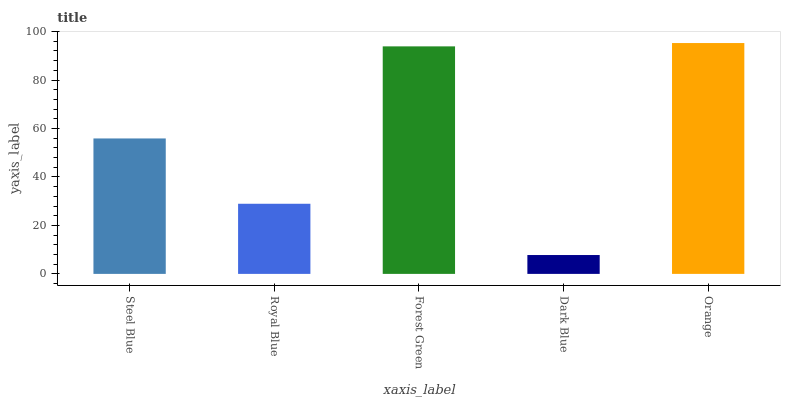Is Dark Blue the minimum?
Answer yes or no. Yes. Is Orange the maximum?
Answer yes or no. Yes. Is Royal Blue the minimum?
Answer yes or no. No. Is Royal Blue the maximum?
Answer yes or no. No. Is Steel Blue greater than Royal Blue?
Answer yes or no. Yes. Is Royal Blue less than Steel Blue?
Answer yes or no. Yes. Is Royal Blue greater than Steel Blue?
Answer yes or no. No. Is Steel Blue less than Royal Blue?
Answer yes or no. No. Is Steel Blue the high median?
Answer yes or no. Yes. Is Steel Blue the low median?
Answer yes or no. Yes. Is Dark Blue the high median?
Answer yes or no. No. Is Orange the low median?
Answer yes or no. No. 